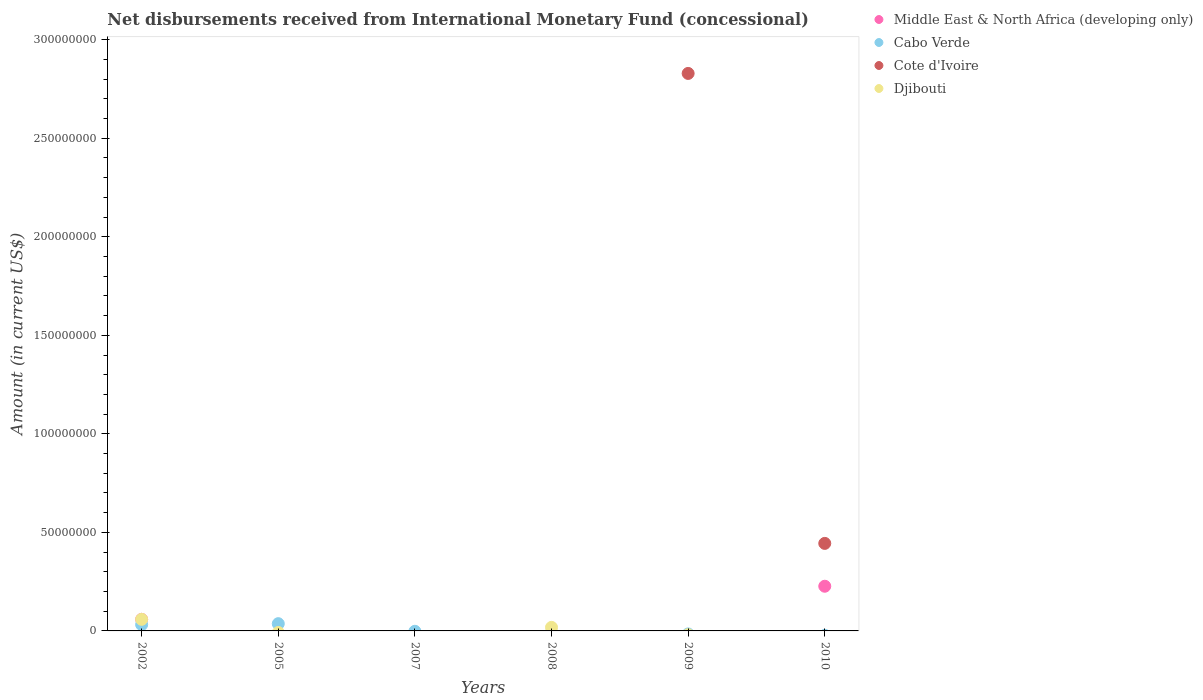How many different coloured dotlines are there?
Provide a succinct answer. 4. What is the amount of disbursements received from International Monetary Fund in Middle East & North Africa (developing only) in 2002?
Your response must be concise. 5.88e+06. Across all years, what is the maximum amount of disbursements received from International Monetary Fund in Cote d'Ivoire?
Keep it short and to the point. 2.83e+08. What is the total amount of disbursements received from International Monetary Fund in Cote d'Ivoire in the graph?
Make the answer very short. 3.27e+08. What is the difference between the amount of disbursements received from International Monetary Fund in Middle East & North Africa (developing only) in 2002 and that in 2010?
Keep it short and to the point. -1.68e+07. What is the difference between the amount of disbursements received from International Monetary Fund in Djibouti in 2002 and the amount of disbursements received from International Monetary Fund in Cabo Verde in 2008?
Provide a succinct answer. 5.88e+06. What is the average amount of disbursements received from International Monetary Fund in Djibouti per year?
Make the answer very short. 1.28e+06. In the year 2010, what is the difference between the amount of disbursements received from International Monetary Fund in Middle East & North Africa (developing only) and amount of disbursements received from International Monetary Fund in Cote d'Ivoire?
Give a very brief answer. -2.17e+07. What is the ratio of the amount of disbursements received from International Monetary Fund in Djibouti in 2002 to that in 2008?
Your answer should be compact. 3.27. What is the difference between the highest and the lowest amount of disbursements received from International Monetary Fund in Cote d'Ivoire?
Offer a terse response. 2.83e+08. Is it the case that in every year, the sum of the amount of disbursements received from International Monetary Fund in Middle East & North Africa (developing only) and amount of disbursements received from International Monetary Fund in Djibouti  is greater than the sum of amount of disbursements received from International Monetary Fund in Cote d'Ivoire and amount of disbursements received from International Monetary Fund in Cabo Verde?
Provide a succinct answer. No. Is it the case that in every year, the sum of the amount of disbursements received from International Monetary Fund in Djibouti and amount of disbursements received from International Monetary Fund in Cabo Verde  is greater than the amount of disbursements received from International Monetary Fund in Middle East & North Africa (developing only)?
Offer a very short reply. No. Does the amount of disbursements received from International Monetary Fund in Cabo Verde monotonically increase over the years?
Your answer should be very brief. No. Is the amount of disbursements received from International Monetary Fund in Cote d'Ivoire strictly less than the amount of disbursements received from International Monetary Fund in Cabo Verde over the years?
Your response must be concise. No. How many years are there in the graph?
Your answer should be very brief. 6. Are the values on the major ticks of Y-axis written in scientific E-notation?
Your response must be concise. No. Does the graph contain any zero values?
Ensure brevity in your answer.  Yes. Does the graph contain grids?
Your response must be concise. No. Where does the legend appear in the graph?
Offer a very short reply. Top right. How are the legend labels stacked?
Your response must be concise. Vertical. What is the title of the graph?
Offer a terse response. Net disbursements received from International Monetary Fund (concessional). Does "Lithuania" appear as one of the legend labels in the graph?
Offer a terse response. No. What is the label or title of the X-axis?
Offer a terse response. Years. What is the label or title of the Y-axis?
Provide a succinct answer. Amount (in current US$). What is the Amount (in current US$) in Middle East & North Africa (developing only) in 2002?
Your answer should be very brief. 5.88e+06. What is the Amount (in current US$) of Cabo Verde in 2002?
Your answer should be very brief. 3.18e+06. What is the Amount (in current US$) in Djibouti in 2002?
Your response must be concise. 5.88e+06. What is the Amount (in current US$) of Middle East & North Africa (developing only) in 2005?
Provide a succinct answer. 0. What is the Amount (in current US$) in Cabo Verde in 2005?
Your answer should be very brief. 3.68e+06. What is the Amount (in current US$) in Djibouti in 2005?
Your answer should be very brief. 0. What is the Amount (in current US$) in Cabo Verde in 2007?
Your answer should be very brief. 0. What is the Amount (in current US$) of Cote d'Ivoire in 2007?
Offer a terse response. 0. What is the Amount (in current US$) of Djibouti in 2007?
Make the answer very short. 0. What is the Amount (in current US$) of Djibouti in 2008?
Provide a succinct answer. 1.80e+06. What is the Amount (in current US$) in Middle East & North Africa (developing only) in 2009?
Your answer should be very brief. 0. What is the Amount (in current US$) of Cabo Verde in 2009?
Your response must be concise. 0. What is the Amount (in current US$) in Cote d'Ivoire in 2009?
Your answer should be very brief. 2.83e+08. What is the Amount (in current US$) of Djibouti in 2009?
Provide a short and direct response. 0. What is the Amount (in current US$) in Middle East & North Africa (developing only) in 2010?
Offer a very short reply. 2.27e+07. What is the Amount (in current US$) of Cote d'Ivoire in 2010?
Your response must be concise. 4.44e+07. What is the Amount (in current US$) of Djibouti in 2010?
Ensure brevity in your answer.  0. Across all years, what is the maximum Amount (in current US$) of Middle East & North Africa (developing only)?
Keep it short and to the point. 2.27e+07. Across all years, what is the maximum Amount (in current US$) in Cabo Verde?
Give a very brief answer. 3.68e+06. Across all years, what is the maximum Amount (in current US$) in Cote d'Ivoire?
Provide a succinct answer. 2.83e+08. Across all years, what is the maximum Amount (in current US$) in Djibouti?
Your answer should be very brief. 5.88e+06. Across all years, what is the minimum Amount (in current US$) of Cabo Verde?
Offer a terse response. 0. Across all years, what is the minimum Amount (in current US$) in Cote d'Ivoire?
Give a very brief answer. 0. Across all years, what is the minimum Amount (in current US$) in Djibouti?
Provide a succinct answer. 0. What is the total Amount (in current US$) in Middle East & North Africa (developing only) in the graph?
Offer a very short reply. 2.86e+07. What is the total Amount (in current US$) of Cabo Verde in the graph?
Provide a succinct answer. 6.86e+06. What is the total Amount (in current US$) in Cote d'Ivoire in the graph?
Offer a terse response. 3.27e+08. What is the total Amount (in current US$) of Djibouti in the graph?
Make the answer very short. 7.68e+06. What is the difference between the Amount (in current US$) in Cabo Verde in 2002 and that in 2005?
Provide a short and direct response. -4.94e+05. What is the difference between the Amount (in current US$) in Djibouti in 2002 and that in 2008?
Your answer should be compact. 4.08e+06. What is the difference between the Amount (in current US$) of Middle East & North Africa (developing only) in 2002 and that in 2010?
Provide a succinct answer. -1.68e+07. What is the difference between the Amount (in current US$) in Cote d'Ivoire in 2009 and that in 2010?
Your answer should be very brief. 2.38e+08. What is the difference between the Amount (in current US$) of Middle East & North Africa (developing only) in 2002 and the Amount (in current US$) of Cabo Verde in 2005?
Make the answer very short. 2.20e+06. What is the difference between the Amount (in current US$) in Middle East & North Africa (developing only) in 2002 and the Amount (in current US$) in Djibouti in 2008?
Your response must be concise. 4.08e+06. What is the difference between the Amount (in current US$) in Cabo Verde in 2002 and the Amount (in current US$) in Djibouti in 2008?
Your response must be concise. 1.39e+06. What is the difference between the Amount (in current US$) of Middle East & North Africa (developing only) in 2002 and the Amount (in current US$) of Cote d'Ivoire in 2009?
Give a very brief answer. -2.77e+08. What is the difference between the Amount (in current US$) in Cabo Verde in 2002 and the Amount (in current US$) in Cote d'Ivoire in 2009?
Provide a short and direct response. -2.80e+08. What is the difference between the Amount (in current US$) of Middle East & North Africa (developing only) in 2002 and the Amount (in current US$) of Cote d'Ivoire in 2010?
Keep it short and to the point. -3.85e+07. What is the difference between the Amount (in current US$) of Cabo Verde in 2002 and the Amount (in current US$) of Cote d'Ivoire in 2010?
Your response must be concise. -4.12e+07. What is the difference between the Amount (in current US$) of Cabo Verde in 2005 and the Amount (in current US$) of Djibouti in 2008?
Your response must be concise. 1.88e+06. What is the difference between the Amount (in current US$) of Cabo Verde in 2005 and the Amount (in current US$) of Cote d'Ivoire in 2009?
Offer a terse response. -2.79e+08. What is the difference between the Amount (in current US$) in Cabo Verde in 2005 and the Amount (in current US$) in Cote d'Ivoire in 2010?
Provide a short and direct response. -4.07e+07. What is the average Amount (in current US$) in Middle East & North Africa (developing only) per year?
Offer a very short reply. 4.76e+06. What is the average Amount (in current US$) in Cabo Verde per year?
Provide a short and direct response. 1.14e+06. What is the average Amount (in current US$) of Cote d'Ivoire per year?
Provide a short and direct response. 5.46e+07. What is the average Amount (in current US$) in Djibouti per year?
Offer a very short reply. 1.28e+06. In the year 2002, what is the difference between the Amount (in current US$) in Middle East & North Africa (developing only) and Amount (in current US$) in Cabo Verde?
Offer a very short reply. 2.70e+06. In the year 2002, what is the difference between the Amount (in current US$) of Middle East & North Africa (developing only) and Amount (in current US$) of Djibouti?
Offer a terse response. 0. In the year 2002, what is the difference between the Amount (in current US$) of Cabo Verde and Amount (in current US$) of Djibouti?
Your response must be concise. -2.70e+06. In the year 2010, what is the difference between the Amount (in current US$) of Middle East & North Africa (developing only) and Amount (in current US$) of Cote d'Ivoire?
Make the answer very short. -2.17e+07. What is the ratio of the Amount (in current US$) of Cabo Verde in 2002 to that in 2005?
Make the answer very short. 0.87. What is the ratio of the Amount (in current US$) of Djibouti in 2002 to that in 2008?
Provide a short and direct response. 3.27. What is the ratio of the Amount (in current US$) in Middle East & North Africa (developing only) in 2002 to that in 2010?
Offer a very short reply. 0.26. What is the ratio of the Amount (in current US$) of Cote d'Ivoire in 2009 to that in 2010?
Give a very brief answer. 6.37. What is the difference between the highest and the lowest Amount (in current US$) in Middle East & North Africa (developing only)?
Keep it short and to the point. 2.27e+07. What is the difference between the highest and the lowest Amount (in current US$) of Cabo Verde?
Ensure brevity in your answer.  3.68e+06. What is the difference between the highest and the lowest Amount (in current US$) in Cote d'Ivoire?
Your response must be concise. 2.83e+08. What is the difference between the highest and the lowest Amount (in current US$) in Djibouti?
Provide a short and direct response. 5.88e+06. 